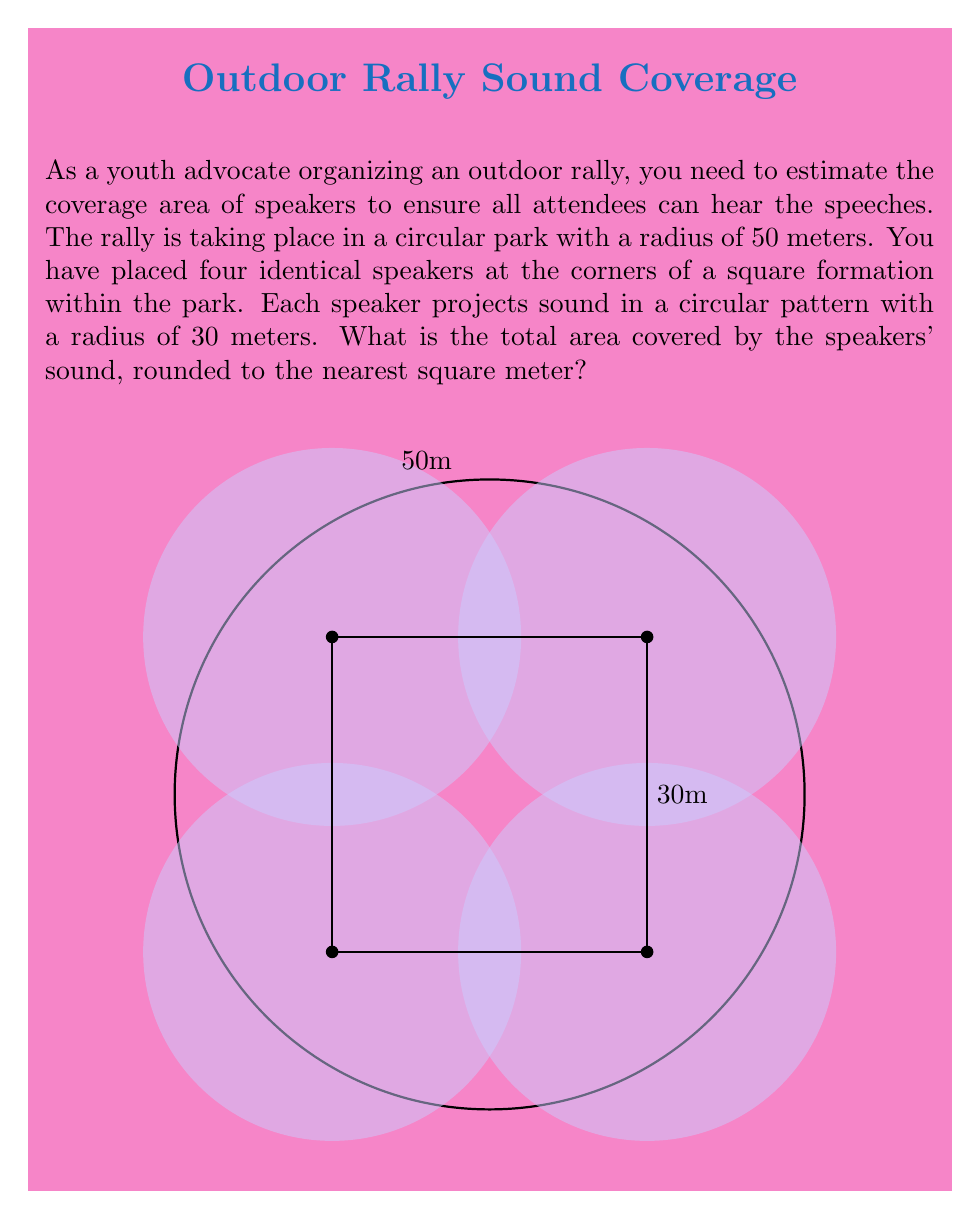Can you solve this math problem? To solve this problem, we'll follow these steps:

1) First, we need to calculate the area covered by a single speaker:
   Area of one speaker = $\pi r^2 = \pi (30^2) = 900\pi$ square meters

2) Now, we have four speakers, so the total area would be $4 * 900\pi = 3600\pi$ square meters if there was no overlap.

3) However, the speakers overlap in the center. To account for this, we need to calculate the area of the square formed by the speaker centers:
   Side of the square = $50$ meters
   Area of the square = $50^2 = 2500$ square meters

4) The area of overlap is approximately equal to the area of this square. So we subtract this from our total:
   Covered area $\approx 3600\pi - 2500 = 1100\pi$ square meters

5) Convert this to a numeric value:
   $1100\pi \approx 3456.99$ square meters

6) Rounding to the nearest square meter:
   $3456.99 \approx 3457$ square meters

Therefore, the total area covered by the speakers' sound is approximately 3457 square meters.
Answer: 3457 m² 